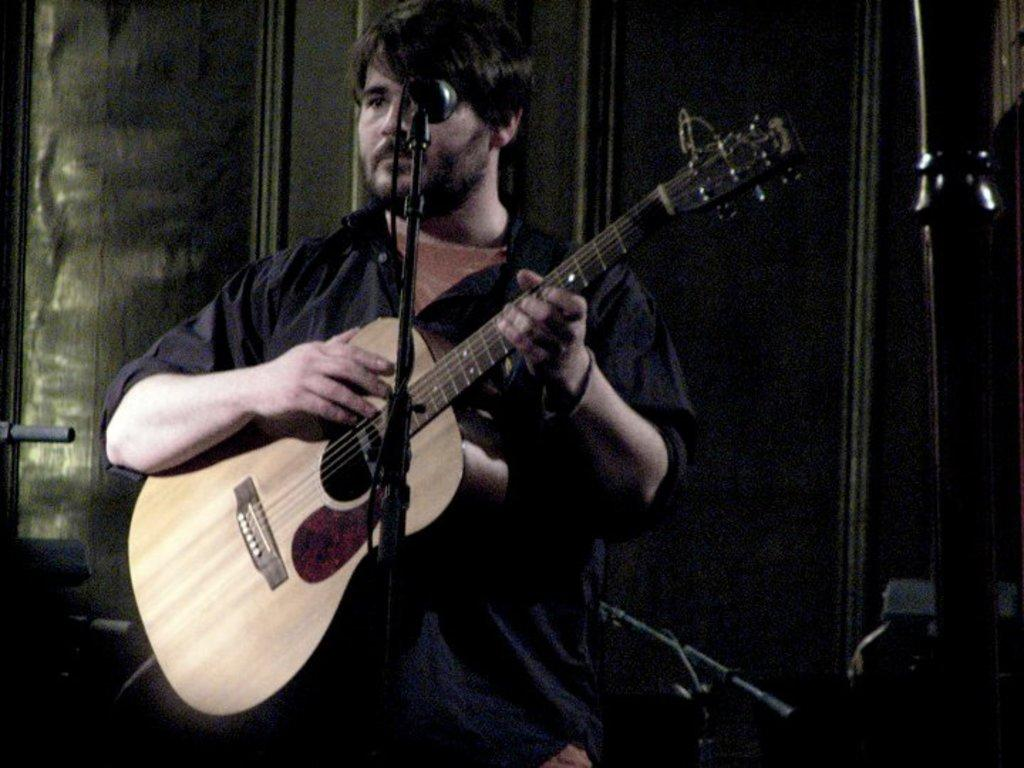Who is the main subject in the image? There is a man in the image. What is the man holding in the image? The man is holding a guitar. What object is in front of the man? There is a microphone in front of the man. How many kittens are playing with the guitar in the image? There are no kittens present in the image, and therefore no such activity can be observed. 